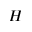<formula> <loc_0><loc_0><loc_500><loc_500>H</formula> 